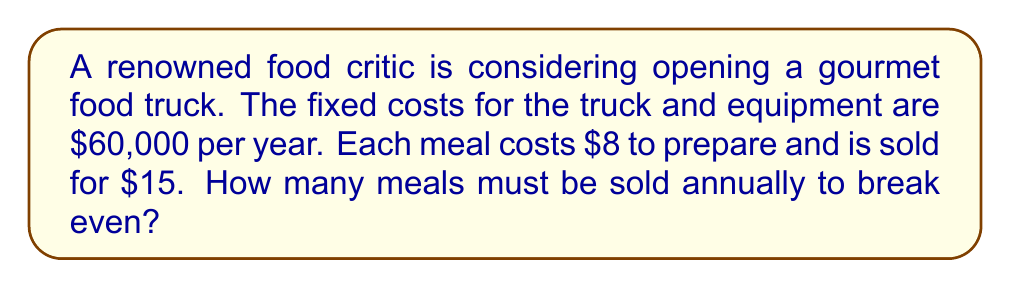Can you solve this math problem? Let's approach this step-by-step:

1. Define variables:
   Let $x$ = number of meals sold annually
   Let $y$ = total revenue

2. Write the equation for total revenue:
   $y = 15x$

3. Write the equation for total costs:
   Total costs = Fixed costs + Variable costs
   $TC = 60000 + 8x$

4. At the break-even point, total revenue equals total costs:
   $15x = 60000 + 8x$

5. Solve the equation:
   $15x - 8x = 60000$
   $7x = 60000$
   $x = \frac{60000}{7} = 8571.43$

6. Since we can't sell a fraction of a meal, we round up to the nearest whole number:
   $x = 8572$ meals
Answer: 8,572 meals 